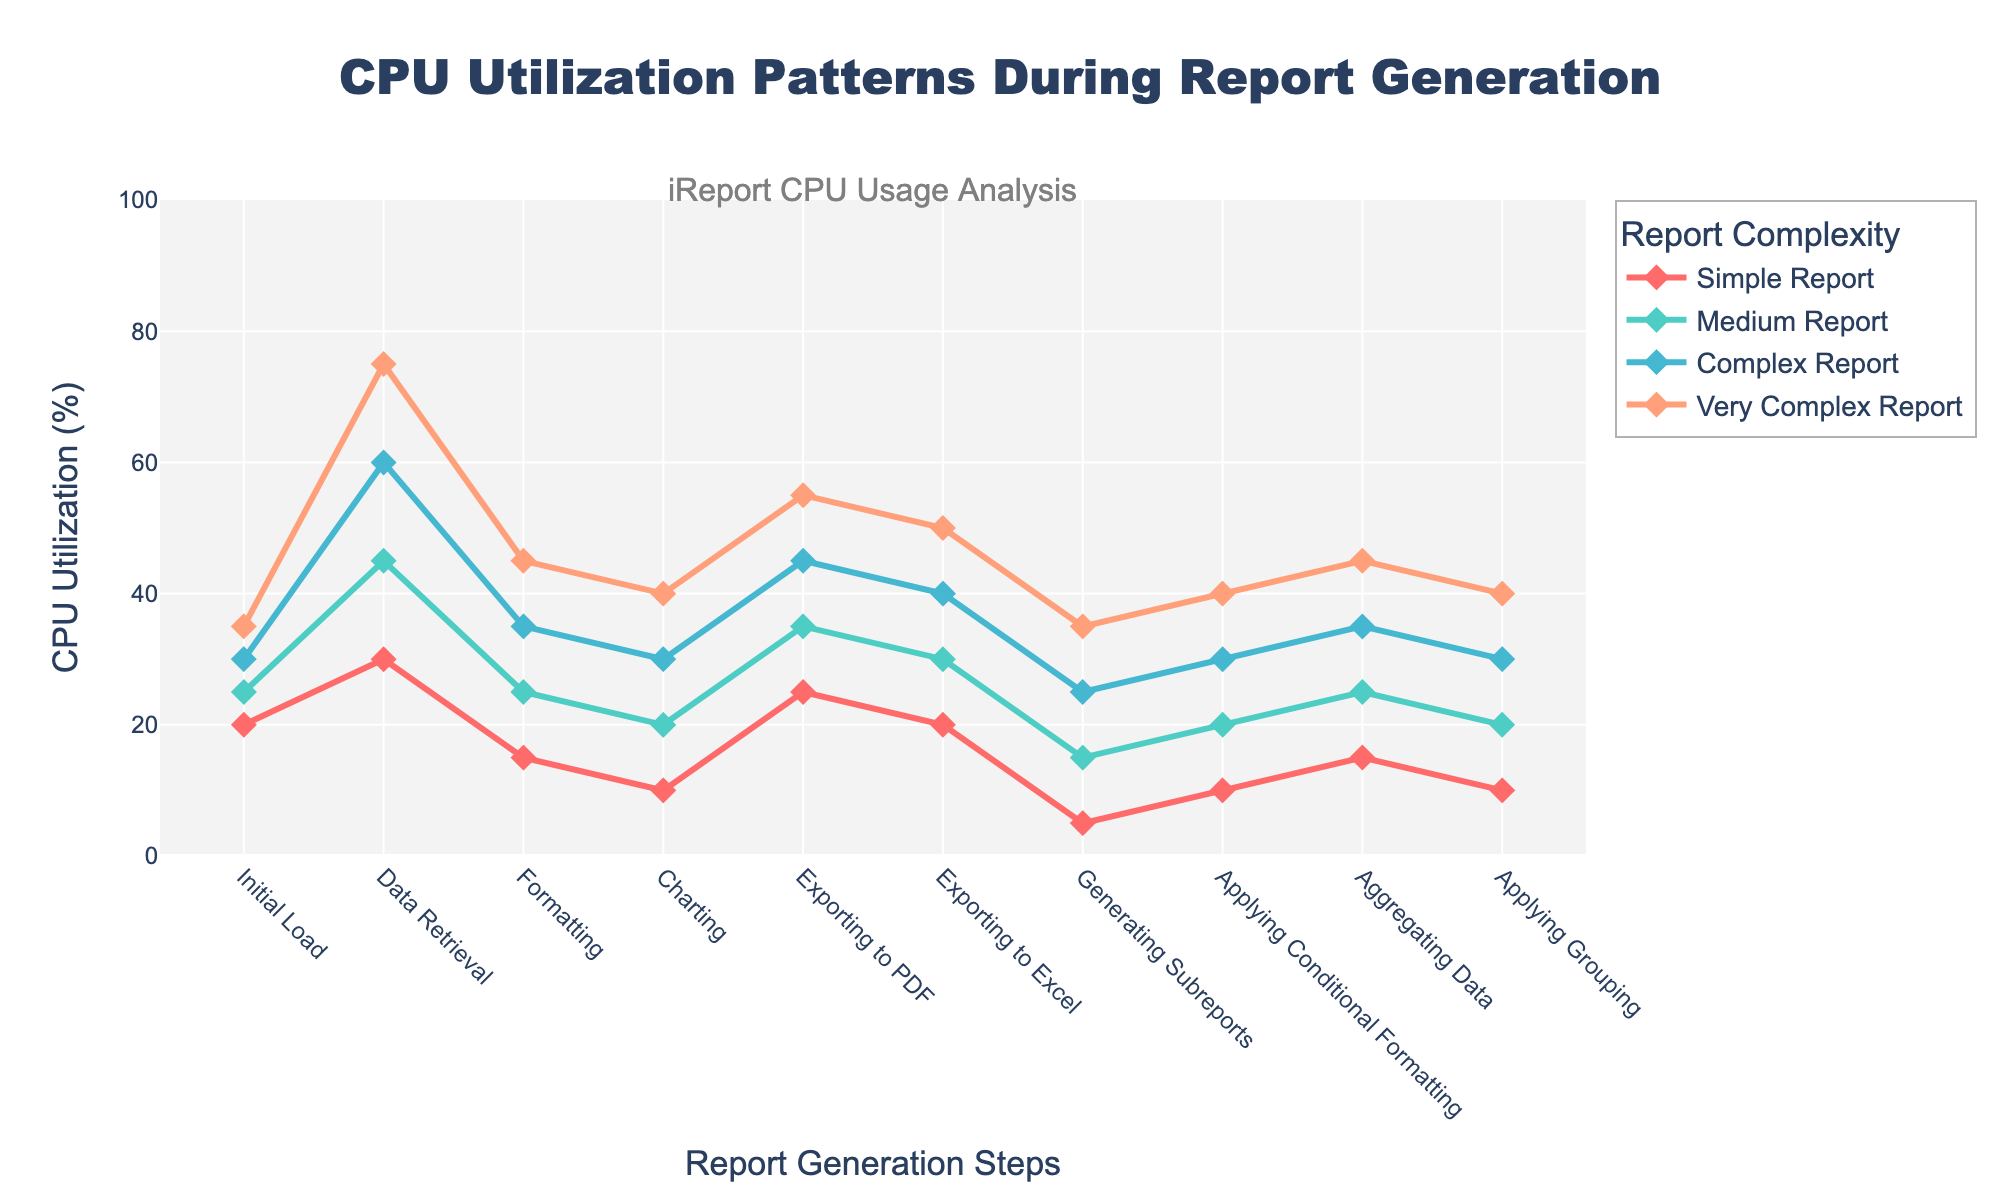What are the CPU utilization values for the "Complex Report" during "Data Retrieval" and "Formatting"? Check the "Complex Report" line on the y-axis for "Data Retrieval" and "Formatting" steps. "Data Retrieval" is 60%, and "Formatting" is 35%.
Answer: 60% for "Data Retrieval" and 35% for "Formatting" Which report complexity has the highest CPU utilization during the "Exporting to Excel" step? Look for the highest point on the y-axis at the "Exporting to Excel" step among all lines. The "Very Complex Report" has the highest value at 50%.
Answer: Very Complex Report What is the difference in CPU utilization between the "Medium Report" and the "Very Complex Report" during the "Applying Conditional Formatting" step? Find the y-axis values for "Medium Report" and "Very Complex Report" during "Applying Conditional Formatting". Medium is 20%, and Very Complex is 40%. The difference is 40% - 20% = 20%.
Answer: 20% What is the average CPU utilization for the "Simple Report" during the "Data Retrieval" and "Applying Grouping" steps? Find the CPU values for the "Simple Report" during "Data Retrieval" (30%) and "Applying Grouping" (10%). The average is (30% + 10%) / 2 = 20%.
Answer: 20% How does the CPU utilization for "Generating Subreports" compare between the "Simple Report" and "Complex Report"? Check the y-axis values for "Generating Subreports" at "Simple Report" (5%) and "Complex Report" (25%). The "Complex Report" is greater.
Answer: Complex Report greater than Simple Report Which report complexity has the most stable (least variable) CPU utilization across all steps? Examine the variability of the lines for each report complexity. "Simple Report" has the least variability as its values are closer together.
Answer: Simple Report What is the sum of the CPU utilization for the "Very Complex Report" during the "Initial Load" and "Charting" steps? Find the CPU utilization values for "Very Complex Report" during "Initial Load" (35%) and "Charting" (40%). The sum is 35% + 40% = 75%.
Answer: 75% What is the CPU utilization trend for the "Medium Report" from "Initial Load" to "Exporting to PDF"? Follow the "Medium Report" line from "Initial Load" (25%) to "Exporting to PDF" (35%). It shows an increasing trend.
Answer: Increasing In which step does the "Medium Report" for CPU utilization change the most compared to the "Simple Report"? Compare the differences between "Medium Report" and "Simple Report" at each step. The largest change is at "Data Retrieval" (45% Medium - 30% Simple = 15%).
Answer: Data Retrieval What is the maximum CPU utilization observed for the "Complex Report"? Look for the highest point along the "Complex Report" line. The highest value observed is 60% at "Data Retrieval".
Answer: 60% 